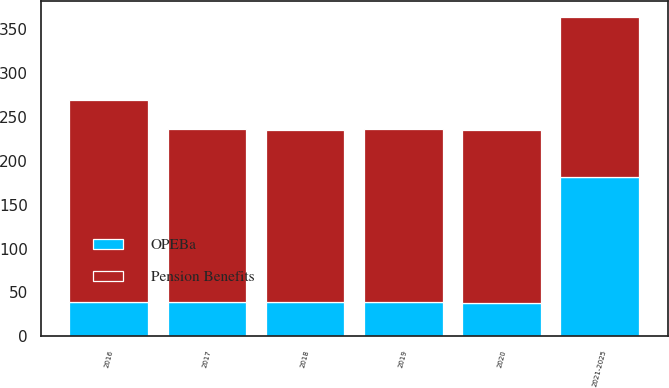Convert chart to OTSL. <chart><loc_0><loc_0><loc_500><loc_500><stacked_bar_chart><ecel><fcel>2016<fcel>2017<fcel>2018<fcel>2019<fcel>2020<fcel>2021-2025<nl><fcel>Pension Benefits<fcel>230<fcel>197<fcel>196<fcel>198<fcel>197<fcel>182<nl><fcel>OPEBa<fcel>39<fcel>39<fcel>39<fcel>39<fcel>38<fcel>182<nl></chart> 